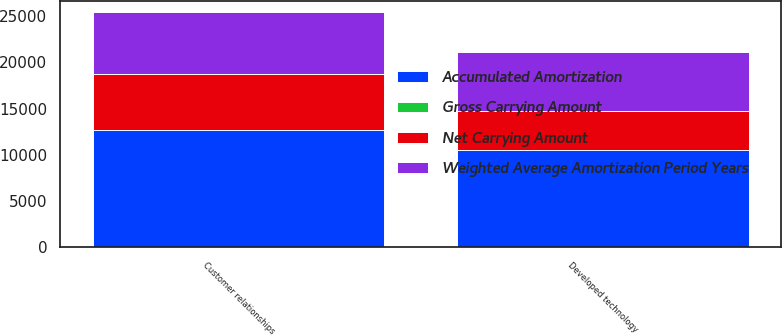<chart> <loc_0><loc_0><loc_500><loc_500><stacked_bar_chart><ecel><fcel>Developed technology<fcel>Customer relationships<nl><fcel>Gross Carrying Amount<fcel>10<fcel>10<nl><fcel>Accumulated Amortization<fcel>10550<fcel>12700<nl><fcel>Weighted Average Amortization Period Years<fcel>6399<fcel>6678<nl><fcel>Net Carrying Amount<fcel>4151<fcel>6022<nl></chart> 